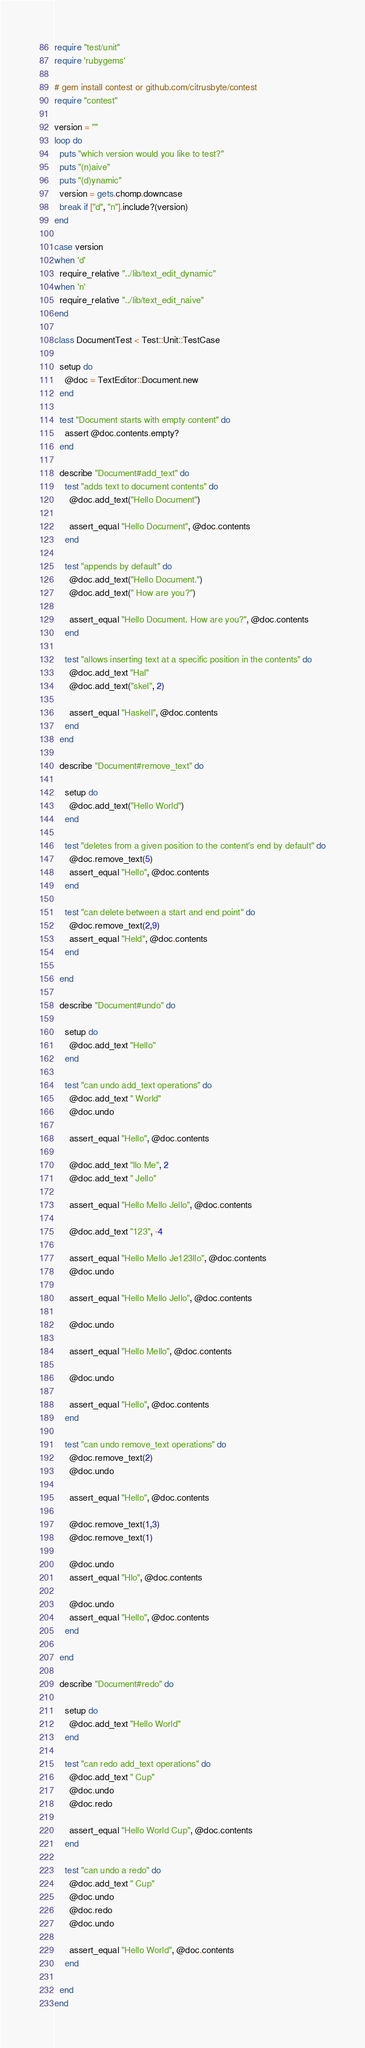Convert code to text. <code><loc_0><loc_0><loc_500><loc_500><_Ruby_>require "test/unit"
require 'rubygems'

# gem install contest or github.com/citrusbyte/contest
require "contest"

version = ""
loop do
  puts "which version would you like to test?"
  puts "(n)aive"
  puts "(d)ynamic"
  version = gets.chomp.downcase
  break if ["d", "n"].include?(version)
end

case version
when 'd'
  require_relative "../lib/text_edit_dynamic"
when 'n'
  require_relative "../lib/text_edit_naive"
end

class DocumentTest < Test::Unit::TestCase

  setup do
    @doc = TextEditor::Document.new
  end

  test "Document starts with empty content" do
    assert @doc.contents.empty?
  end

  describe "Document#add_text" do
    test "adds text to document contents" do
      @doc.add_text("Hello Document")

      assert_equal "Hello Document", @doc.contents
    end

    test "appends by default" do
      @doc.add_text("Hello Document.")
      @doc.add_text(" How are you?")

      assert_equal "Hello Document. How are you?", @doc.contents
    end

    test "allows inserting text at a specific position in the contents" do
      @doc.add_text "Hal"
      @doc.add_text("skel", 2)

      assert_equal "Haskell", @doc.contents
    end
  end

  describe "Document#remove_text" do

    setup do
      @doc.add_text("Hello World")
    end

    test "deletes from a given position to the content's end by default" do
      @doc.remove_text(5)
      assert_equal "Hello", @doc.contents
    end

    test "can delete between a start and end point" do
      @doc.remove_text(2,9)
      assert_equal "Held", @doc.contents
    end

  end

  describe "Document#undo" do

    setup do
      @doc.add_text "Hello"
    end

    test "can undo add_text operations" do
      @doc.add_text " World"
      @doc.undo

      assert_equal "Hello", @doc.contents

      @doc.add_text "llo Me", 2
      @doc.add_text " Jello"

      assert_equal "Hello Mello Jello", @doc.contents

      @doc.add_text "123", -4

      assert_equal "Hello Mello Je123llo", @doc.contents
      @doc.undo

      assert_equal "Hello Mello Jello", @doc.contents

      @doc.undo

      assert_equal "Hello Mello", @doc.contents

      @doc.undo

      assert_equal "Hello", @doc.contents
    end

    test "can undo remove_text operations" do
      @doc.remove_text(2)
      @doc.undo

      assert_equal "Hello", @doc.contents

      @doc.remove_text(1,3)
      @doc.remove_text(1)

      @doc.undo
      assert_equal "Hlo", @doc.contents

      @doc.undo
      assert_equal "Hello", @doc.contents
    end

  end

  describe "Document#redo" do

    setup do
      @doc.add_text "Hello World"
    end

    test "can redo add_text operations" do
      @doc.add_text " Cup"
      @doc.undo
      @doc.redo

      assert_equal "Hello World Cup", @doc.contents
    end

    test "can undo a redo" do
      @doc.add_text " Cup"
      @doc.undo
      @doc.redo
      @doc.undo

      assert_equal "Hello World", @doc.contents
    end

  end
end
</code> 